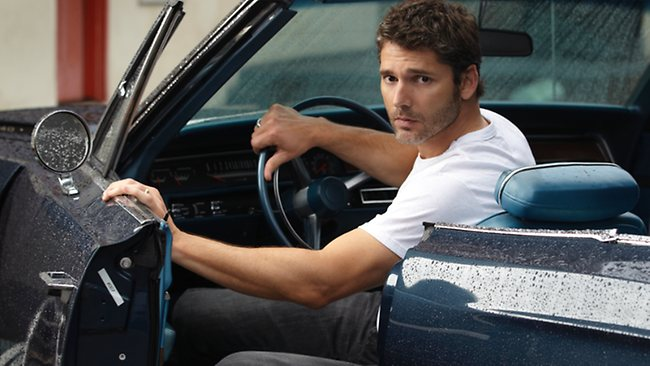Can you tell me more about the car's design and era? This blue car features a classic design indicative of muscle cars from the 1970s or 1980s. It has a robust, angular body shape and a distinctive metallic blue finish. Interior elements visible such as the dashboard and steering wheel suggest a blend of vintage and simplistic style, typical of performance-oriented vehicles of that period. How does this setting enhance the overall feel of the image? The garage setting with its stark red wall serves as a vivid backdrop that contrasts with the car's blue, enhancing the vehicle's visual appeal and adding a raw, mechanical vibe to the scene. This setting underscores themes of solitude and preparation, enhancing the narrative of impending action. 